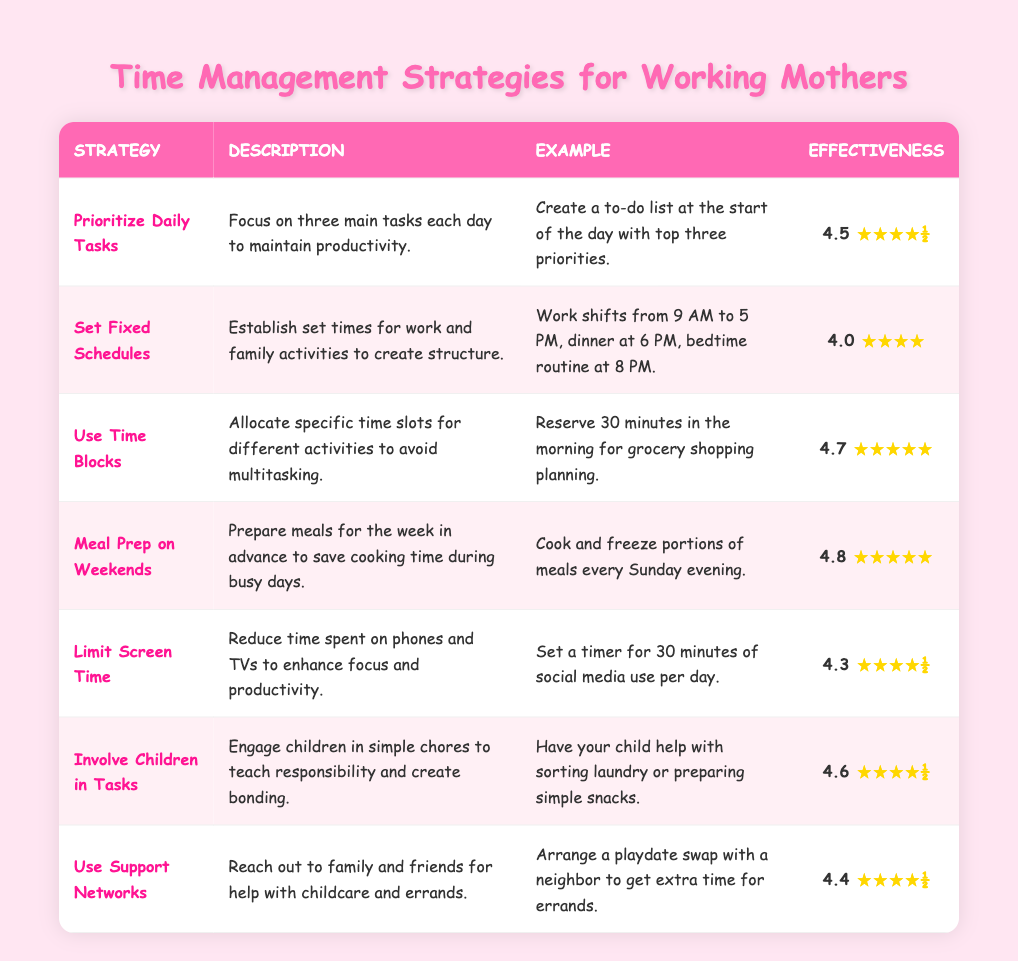What is the effectiveness rating of "Meal Prep on Weekends"? The table shows "Meal Prep on Weekends" has an effectiveness rating of 4.8.
Answer: 4.8 Which strategy has the highest effectiveness rating? By comparing the effectiveness ratings in the table, "Meal Prep on Weekends" has the highest rating at 4.8.
Answer: Meal Prep on Weekends How many strategies have an effectiveness rating of 4.5 or higher? The strategies with ratings of 4.5 or higher are "Prioritize Daily Tasks", "Use Time Blocks", "Meal Prep on Weekends", "Involve Children in Tasks", and "Use Support Networks". This totals 5 strategies.
Answer: 5 Is the effectiveness rating for "Set Fixed Schedules" higher than that of "Limit Screen Time"? "Set Fixed Schedules" has a rating of 4.0 while "Limit Screen Time" has a rating of 4.3. Since 4.0 is less than 4.3, the answer is no.
Answer: No If you average the effectiveness ratings of all the strategies, what is the result? The ratings are: 4.5, 4.0, 4.7, 4.8, 4.3, 4.6, and 4.4. Adding these gives 27.5. Dividing by 7 (the number of strategies) results in an average of 3.93.
Answer: 3.93 Which strategy involves engaging children in household tasks? The table indicates that "Involve Children in Tasks" focuses on engaging children in chores.
Answer: Involve Children in Tasks What time management strategy includes meal preparation for the week? "Meal Prep on Weekends" is the strategy focused on preparing meals for the week in advance.
Answer: Meal Prep on Weekends Is there a strategy that combines family responsibility with bonding? "Involve Children in Tasks" combines teaching responsibility and bonding with children through simple chores. Yes, this strategy fulfills that aspect.
Answer: Yes 